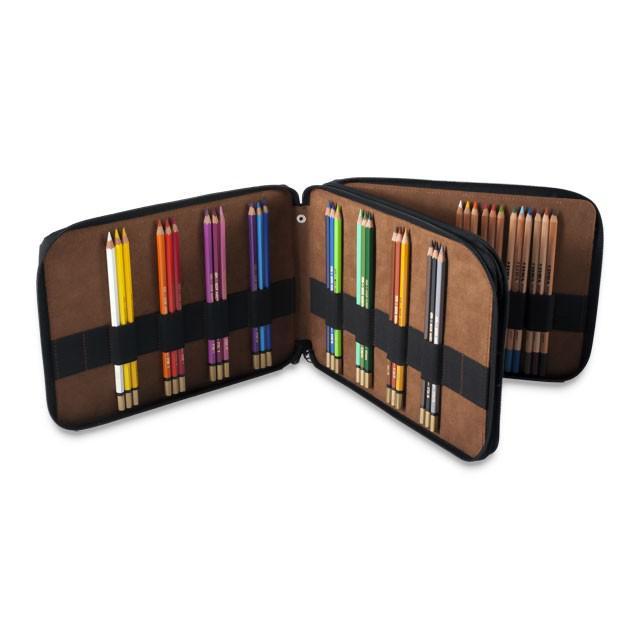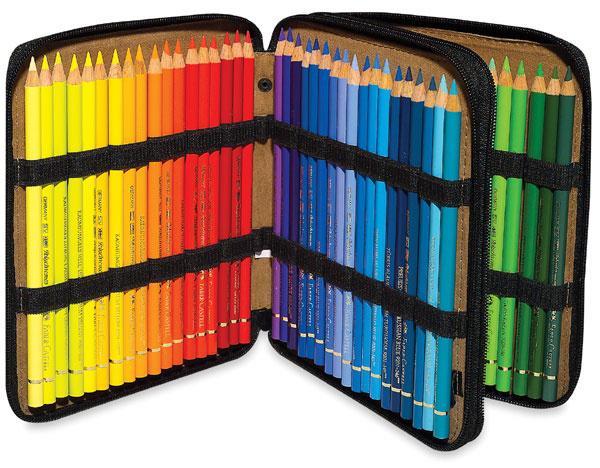The first image is the image on the left, the second image is the image on the right. Considering the images on both sides, is "The cases in both images are currently storing only colored pencils." valid? Answer yes or no. Yes. The first image is the image on the left, the second image is the image on the right. Considering the images on both sides, is "One binder is displayed upright with its three filled sections fanned out and each section shorter than it is wide." valid? Answer yes or no. Yes. 